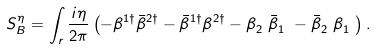Convert formula to latex. <formula><loc_0><loc_0><loc_500><loc_500>S ^ { \eta } _ { B } = \int _ { r } \frac { { i } \eta } { 2 \pi } \left ( - \beta ^ { 1 \dag } \bar { \beta } ^ { 2 \dag } - \bar { \beta } ^ { 1 \dag } \beta ^ { 2 \dag } - \beta ^ { \ } _ { 2 } \bar { \beta } ^ { \ } _ { 1 } - \bar { \beta } ^ { \ } _ { 2 } \beta ^ { \ } _ { 1 } \right ) .</formula> 